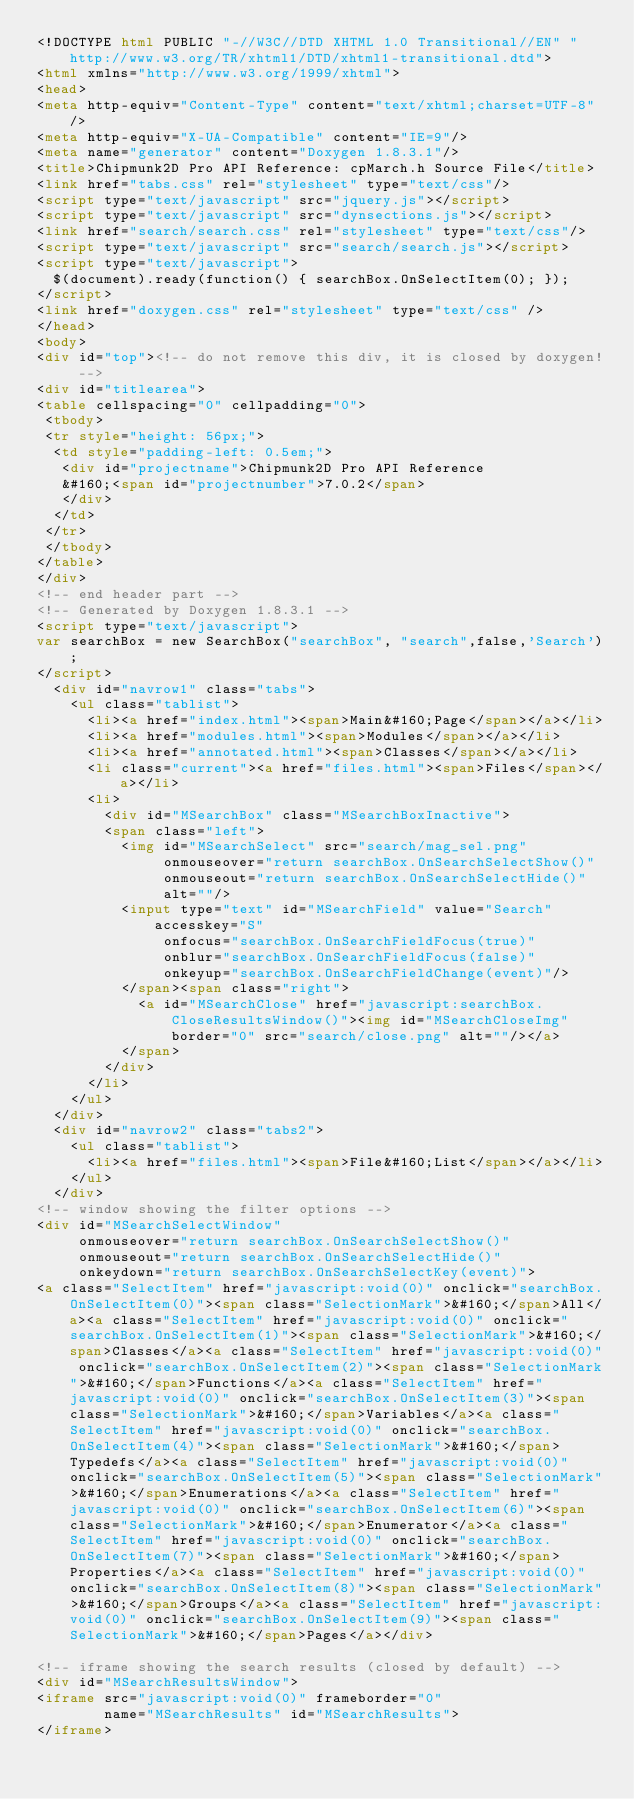<code> <loc_0><loc_0><loc_500><loc_500><_HTML_><!DOCTYPE html PUBLIC "-//W3C//DTD XHTML 1.0 Transitional//EN" "http://www.w3.org/TR/xhtml1/DTD/xhtml1-transitional.dtd">
<html xmlns="http://www.w3.org/1999/xhtml">
<head>
<meta http-equiv="Content-Type" content="text/xhtml;charset=UTF-8"/>
<meta http-equiv="X-UA-Compatible" content="IE=9"/>
<meta name="generator" content="Doxygen 1.8.3.1"/>
<title>Chipmunk2D Pro API Reference: cpMarch.h Source File</title>
<link href="tabs.css" rel="stylesheet" type="text/css"/>
<script type="text/javascript" src="jquery.js"></script>
<script type="text/javascript" src="dynsections.js"></script>
<link href="search/search.css" rel="stylesheet" type="text/css"/>
<script type="text/javascript" src="search/search.js"></script>
<script type="text/javascript">
  $(document).ready(function() { searchBox.OnSelectItem(0); });
</script>
<link href="doxygen.css" rel="stylesheet" type="text/css" />
</head>
<body>
<div id="top"><!-- do not remove this div, it is closed by doxygen! -->
<div id="titlearea">
<table cellspacing="0" cellpadding="0">
 <tbody>
 <tr style="height: 56px;">
  <td style="padding-left: 0.5em;">
   <div id="projectname">Chipmunk2D Pro API Reference
   &#160;<span id="projectnumber">7.0.2</span>
   </div>
  </td>
 </tr>
 </tbody>
</table>
</div>
<!-- end header part -->
<!-- Generated by Doxygen 1.8.3.1 -->
<script type="text/javascript">
var searchBox = new SearchBox("searchBox", "search",false,'Search');
</script>
  <div id="navrow1" class="tabs">
    <ul class="tablist">
      <li><a href="index.html"><span>Main&#160;Page</span></a></li>
      <li><a href="modules.html"><span>Modules</span></a></li>
      <li><a href="annotated.html"><span>Classes</span></a></li>
      <li class="current"><a href="files.html"><span>Files</span></a></li>
      <li>
        <div id="MSearchBox" class="MSearchBoxInactive">
        <span class="left">
          <img id="MSearchSelect" src="search/mag_sel.png"
               onmouseover="return searchBox.OnSearchSelectShow()"
               onmouseout="return searchBox.OnSearchSelectHide()"
               alt=""/>
          <input type="text" id="MSearchField" value="Search" accesskey="S"
               onfocus="searchBox.OnSearchFieldFocus(true)" 
               onblur="searchBox.OnSearchFieldFocus(false)" 
               onkeyup="searchBox.OnSearchFieldChange(event)"/>
          </span><span class="right">
            <a id="MSearchClose" href="javascript:searchBox.CloseResultsWindow()"><img id="MSearchCloseImg" border="0" src="search/close.png" alt=""/></a>
          </span>
        </div>
      </li>
    </ul>
  </div>
  <div id="navrow2" class="tabs2">
    <ul class="tablist">
      <li><a href="files.html"><span>File&#160;List</span></a></li>
    </ul>
  </div>
<!-- window showing the filter options -->
<div id="MSearchSelectWindow"
     onmouseover="return searchBox.OnSearchSelectShow()"
     onmouseout="return searchBox.OnSearchSelectHide()"
     onkeydown="return searchBox.OnSearchSelectKey(event)">
<a class="SelectItem" href="javascript:void(0)" onclick="searchBox.OnSelectItem(0)"><span class="SelectionMark">&#160;</span>All</a><a class="SelectItem" href="javascript:void(0)" onclick="searchBox.OnSelectItem(1)"><span class="SelectionMark">&#160;</span>Classes</a><a class="SelectItem" href="javascript:void(0)" onclick="searchBox.OnSelectItem(2)"><span class="SelectionMark">&#160;</span>Functions</a><a class="SelectItem" href="javascript:void(0)" onclick="searchBox.OnSelectItem(3)"><span class="SelectionMark">&#160;</span>Variables</a><a class="SelectItem" href="javascript:void(0)" onclick="searchBox.OnSelectItem(4)"><span class="SelectionMark">&#160;</span>Typedefs</a><a class="SelectItem" href="javascript:void(0)" onclick="searchBox.OnSelectItem(5)"><span class="SelectionMark">&#160;</span>Enumerations</a><a class="SelectItem" href="javascript:void(0)" onclick="searchBox.OnSelectItem(6)"><span class="SelectionMark">&#160;</span>Enumerator</a><a class="SelectItem" href="javascript:void(0)" onclick="searchBox.OnSelectItem(7)"><span class="SelectionMark">&#160;</span>Properties</a><a class="SelectItem" href="javascript:void(0)" onclick="searchBox.OnSelectItem(8)"><span class="SelectionMark">&#160;</span>Groups</a><a class="SelectItem" href="javascript:void(0)" onclick="searchBox.OnSelectItem(9)"><span class="SelectionMark">&#160;</span>Pages</a></div>

<!-- iframe showing the search results (closed by default) -->
<div id="MSearchResultsWindow">
<iframe src="javascript:void(0)" frameborder="0" 
        name="MSearchResults" id="MSearchResults">
</iframe></code> 